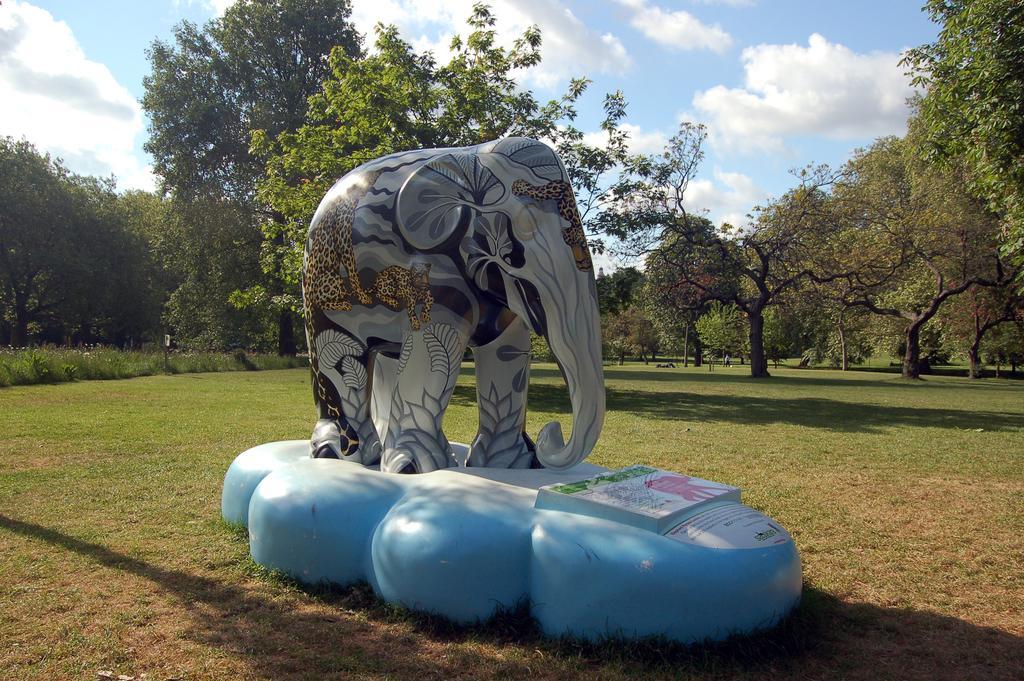Could you give a brief overview of what you see in this image? In this picture we can see the statue of an elephant and a few things on an object. We can see the paintings of animals and other things on the statue of an elephant. There is some grass on the ground. We can see plants, trees, other objects and the cloudy sky. 